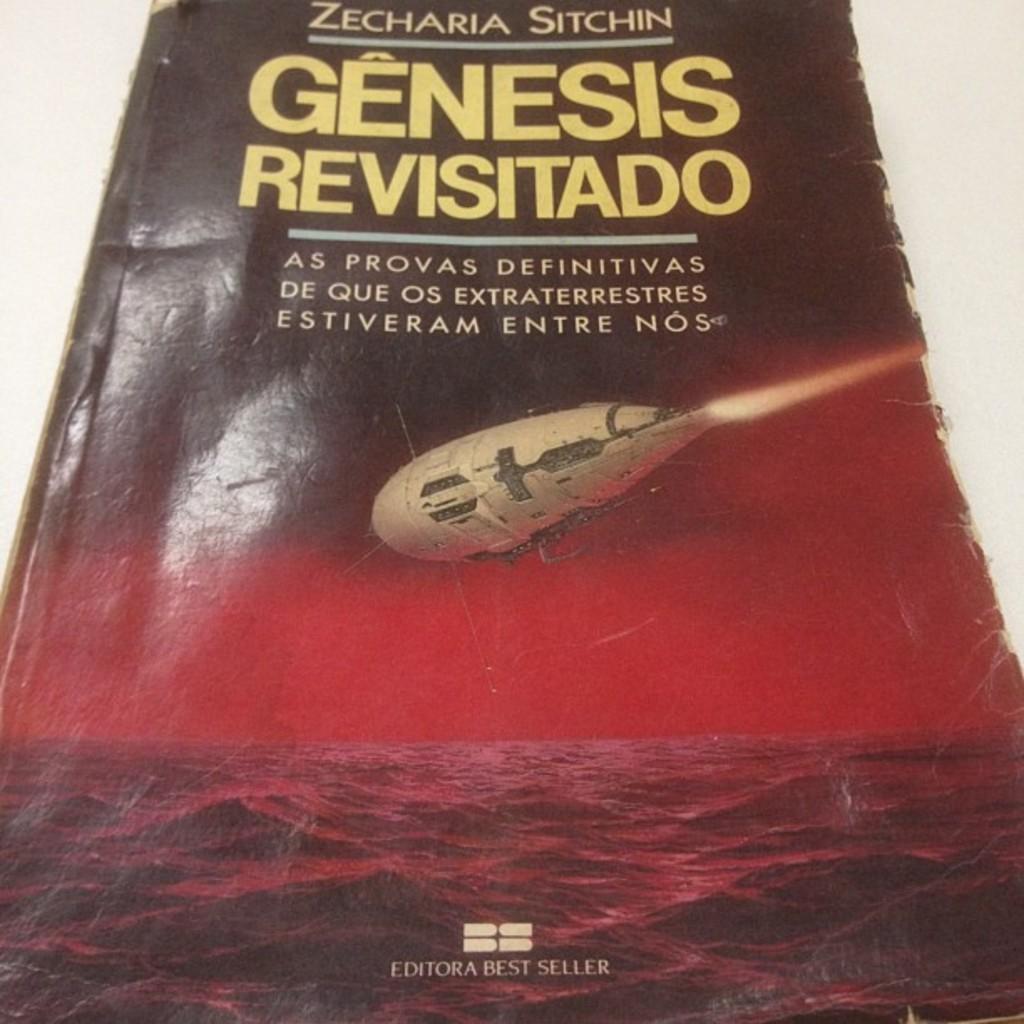What´s the title of this book?
Provide a short and direct response. Genesis revisitado. 